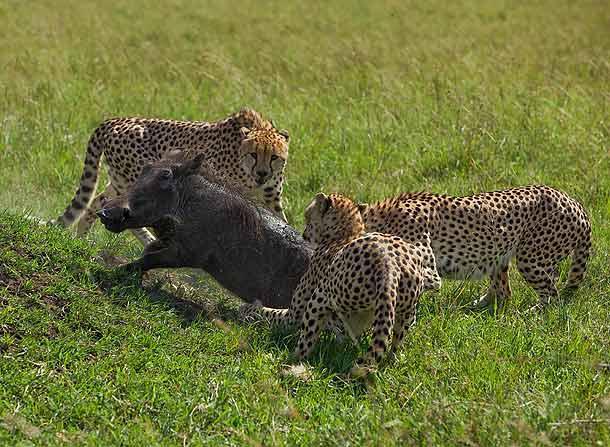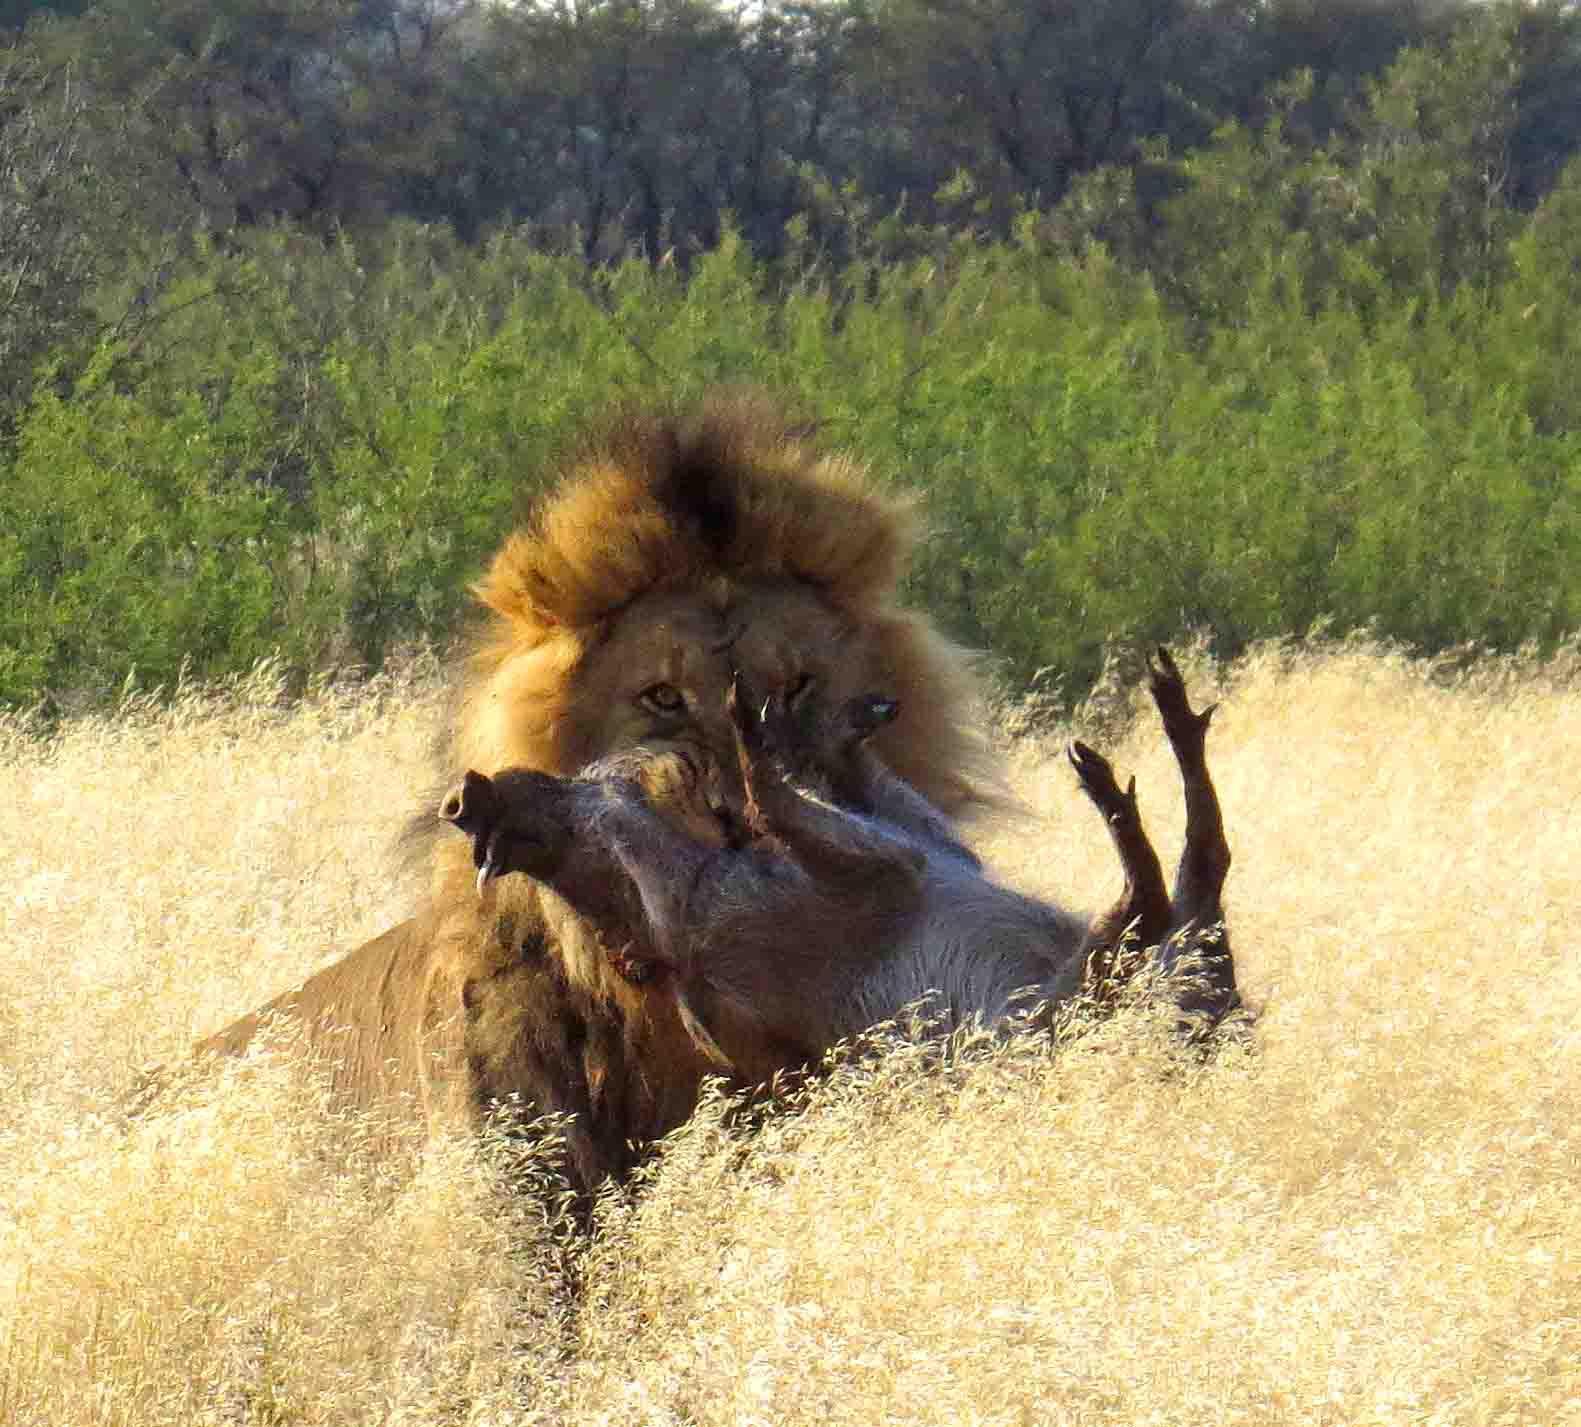The first image is the image on the left, the second image is the image on the right. Assess this claim about the two images: "One of the images shows an animal in close proximity to water.". Correct or not? Answer yes or no. No. The first image is the image on the left, the second image is the image on the right. Assess this claim about the two images: "All the animals appear in front of a completely green background.". Correct or not? Answer yes or no. Yes. 